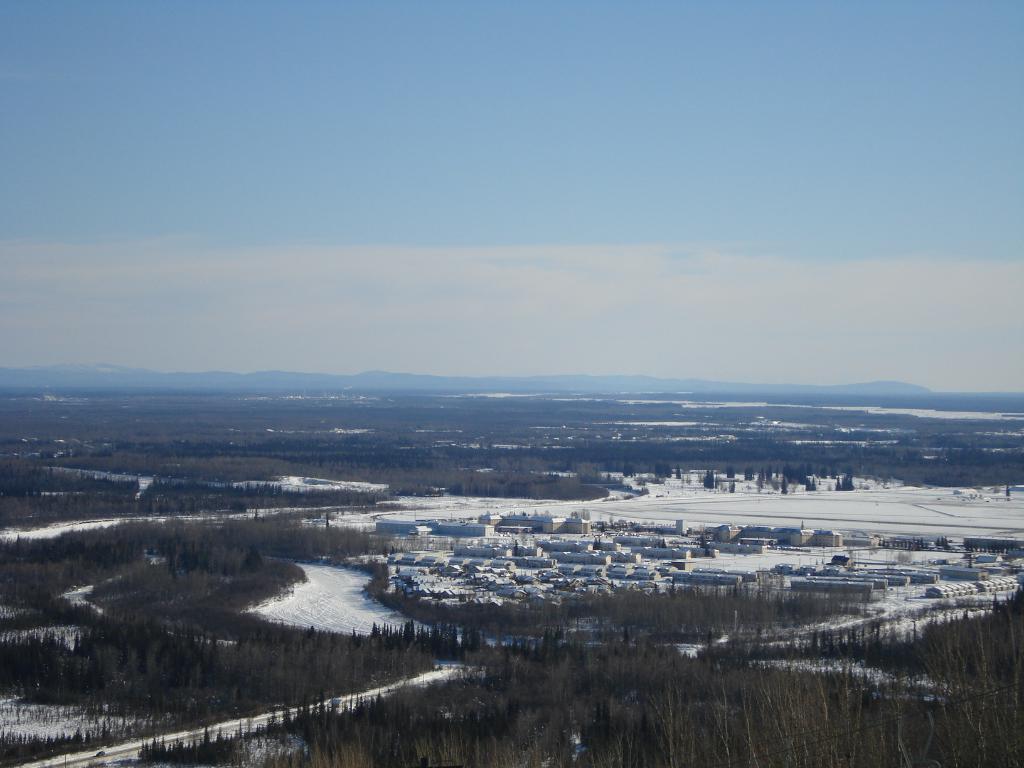How would you summarize this image in a sentence or two? This picture is clicked outside the city. In the foreground we can see the trees. In the center there is a lot of snow and we can see the buildings and houses. In the background there is a sky and some other items. 